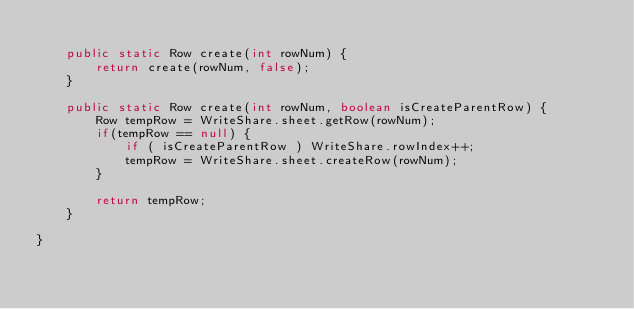<code> <loc_0><loc_0><loc_500><loc_500><_Java_>	
	public static Row create(int rowNum) {
		return create(rowNum, false);
	}
	
	public static Row create(int rowNum, boolean isCreateParentRow) {
		Row tempRow = WriteShare.sheet.getRow(rowNum);
		if(tempRow == null) {
			if ( isCreateParentRow ) WriteShare.rowIndex++;
			tempRow = WriteShare.sheet.createRow(rowNum);
		}
		
		return tempRow;
	}
	
}
</code> 